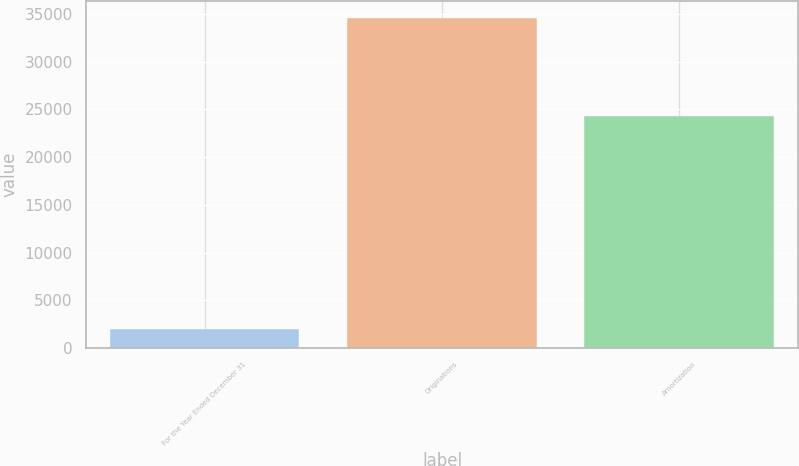Convert chart to OTSL. <chart><loc_0><loc_0><loc_500><loc_500><bar_chart><fcel>For the Year Ended December 31<fcel>Originations<fcel>Amortization<nl><fcel>2017<fcel>34620<fcel>24308<nl></chart> 